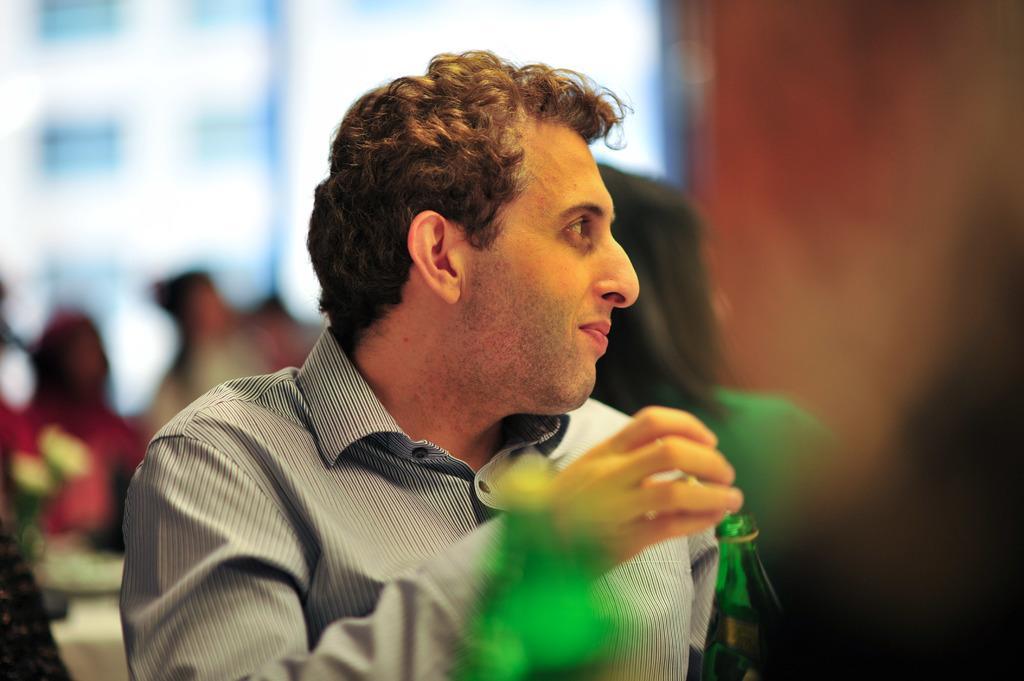Could you give a brief overview of what you see in this image? In this image we can see a man smiling, is sitting on the chair near the table, is holding a bottle in his hands. 